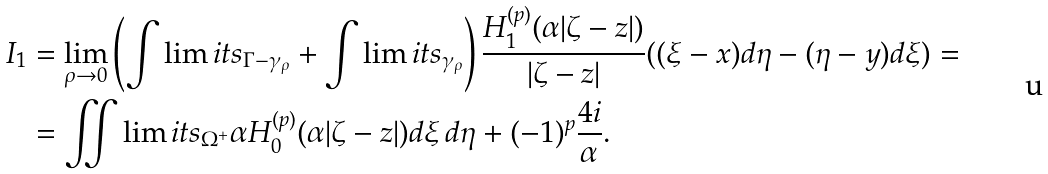Convert formula to latex. <formula><loc_0><loc_0><loc_500><loc_500>I _ { 1 } & = \lim _ { \rho \to 0 } \left ( \int \lim i t s _ { \Gamma - \gamma _ { \rho } } + \int \lim i t s _ { \gamma _ { \rho } } \right ) \frac { H _ { 1 } ^ { ( p ) } ( \alpha | \zeta - z | ) } { | \zeta - z | } ( ( \xi - x ) d \eta - ( \eta - y ) d \xi ) = \\ & = \iint \lim i t s _ { \Omega ^ { + } } \alpha H _ { 0 } ^ { ( p ) } ( \alpha | \zeta - z | ) d \xi \, d \eta + ( - 1 ) ^ { p } \frac { 4 i } { \alpha } .</formula> 